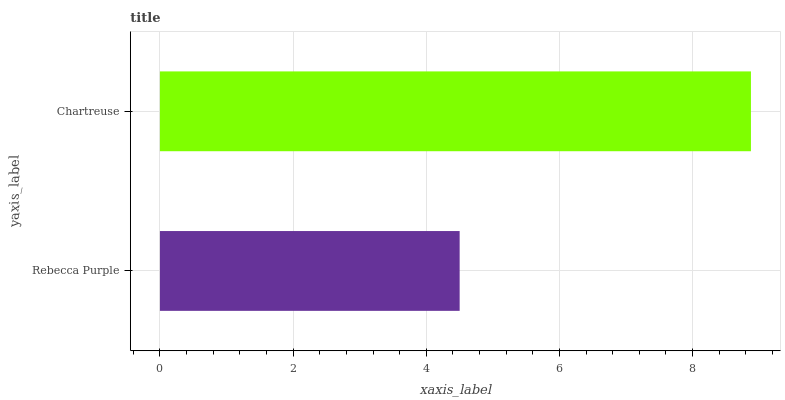Is Rebecca Purple the minimum?
Answer yes or no. Yes. Is Chartreuse the maximum?
Answer yes or no. Yes. Is Chartreuse the minimum?
Answer yes or no. No. Is Chartreuse greater than Rebecca Purple?
Answer yes or no. Yes. Is Rebecca Purple less than Chartreuse?
Answer yes or no. Yes. Is Rebecca Purple greater than Chartreuse?
Answer yes or no. No. Is Chartreuse less than Rebecca Purple?
Answer yes or no. No. Is Chartreuse the high median?
Answer yes or no. Yes. Is Rebecca Purple the low median?
Answer yes or no. Yes. Is Rebecca Purple the high median?
Answer yes or no. No. Is Chartreuse the low median?
Answer yes or no. No. 